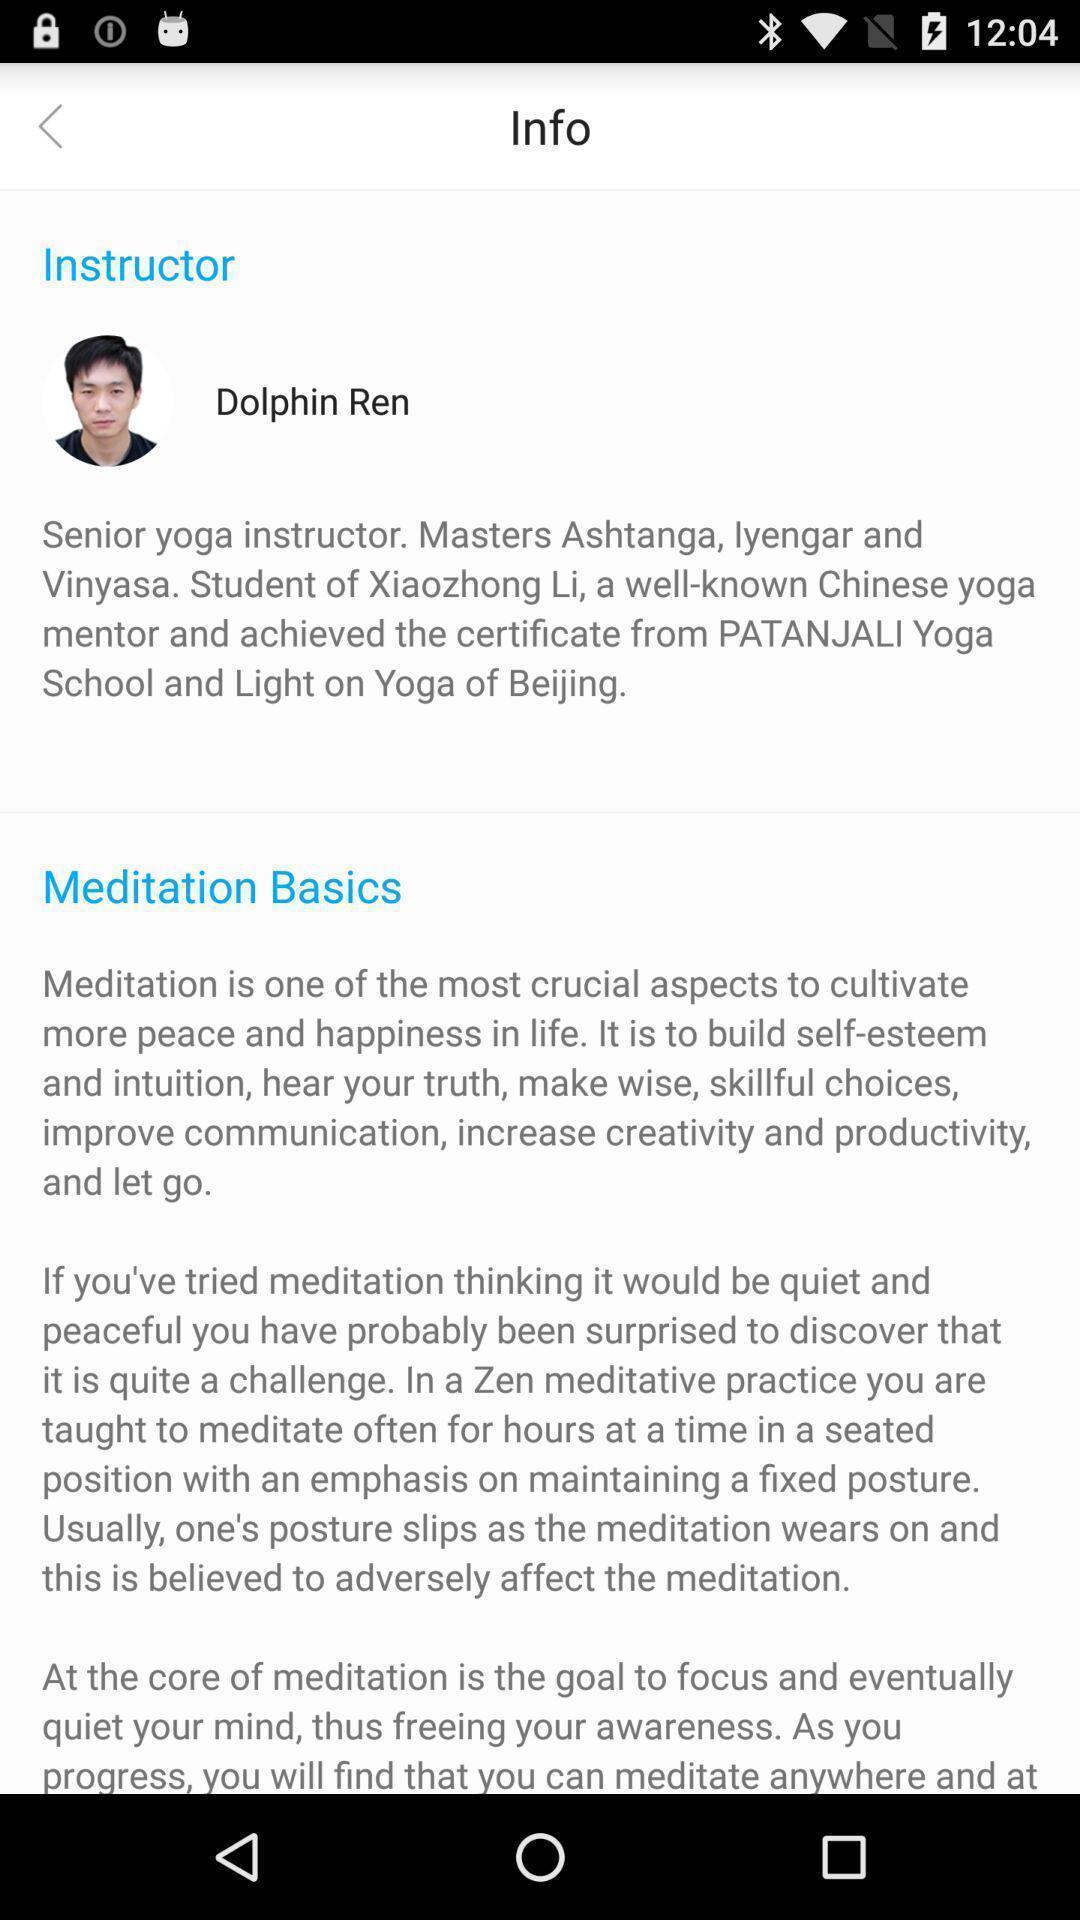Explain what's happening in this screen capture. Page with information in an application. 